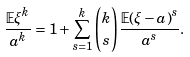<formula> <loc_0><loc_0><loc_500><loc_500>\frac { \mathbb { E } \xi ^ { k } } { a ^ { k } } = 1 + \sum _ { s = 1 } ^ { k } { k \choose s } \frac { \mathbb { E } ( \xi - a ) ^ { s } } { a ^ { s } } .</formula> 